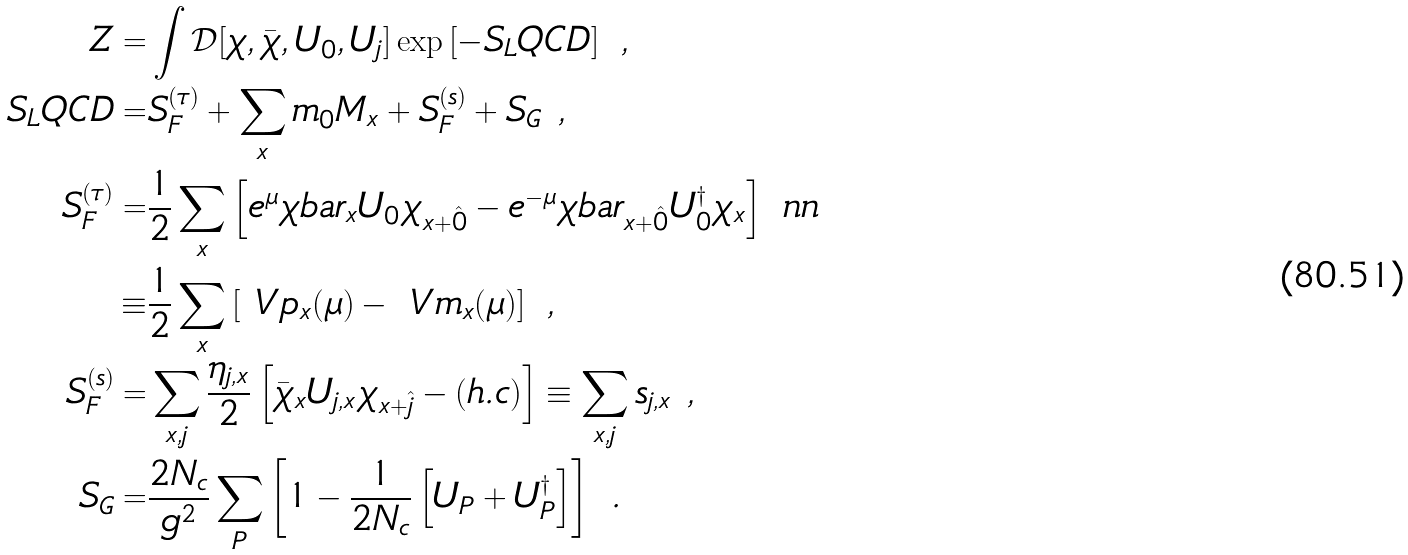<formula> <loc_0><loc_0><loc_500><loc_500>Z = & \int \mathcal { D } [ \chi , \bar { \chi } , U _ { 0 } , U _ { j } ] \exp \left [ - S _ { L } Q C D \right ] \ , \\ S _ { L } Q C D = & S _ { F } ^ { ( \tau ) } + \sum _ { x } m _ { 0 } M _ { x } + S _ { F } ^ { ( s ) } + S _ { G } \ , \\ S _ { F } ^ { ( \tau ) } = & \frac { 1 } { 2 } \sum _ { x } \left [ e ^ { \mu } \chi b a r _ { x } U _ { 0 } \chi _ { x + \hat { 0 } } - e ^ { - \mu } \chi b a r _ { x + \hat { 0 } } U ^ { \dagger } _ { 0 } \chi _ { x } \right ] \ n n \\ \equiv & \frac { 1 } { 2 } \sum _ { x } \left [ \ V p _ { x } ( \mu ) - \ V m _ { x } ( \mu ) \right ] \ , \\ S _ { F } ^ { ( s ) } = & \sum _ { x , j } \frac { \eta _ { j , x } } { 2 } \left [ \bar { \chi } _ { x } U _ { j , x } \chi _ { x + \hat { j } } - ( h . c ) \right ] \equiv \sum _ { x , j } s _ { j , x } \ , \\ S _ { G } = & \frac { 2 N _ { c } } { g ^ { 2 } } \sum _ { P } \left [ 1 - \frac { 1 } { 2 N _ { c } } \left [ U _ { P } + U _ { P } ^ { \dagger } \right ] \right ] \ .</formula> 